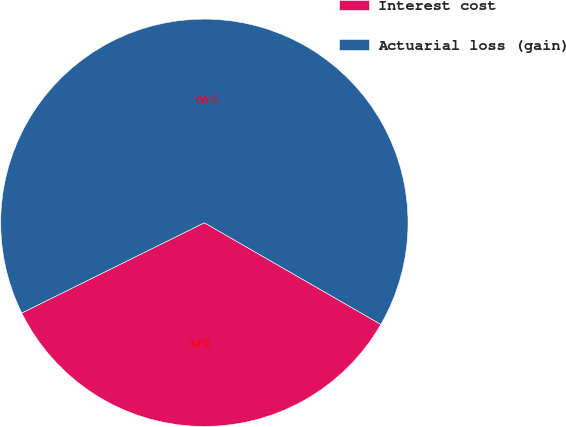Convert chart. <chart><loc_0><loc_0><loc_500><loc_500><pie_chart><fcel>Interest cost<fcel>Actuarial loss (gain)<nl><fcel>34.38%<fcel>65.62%<nl></chart> 